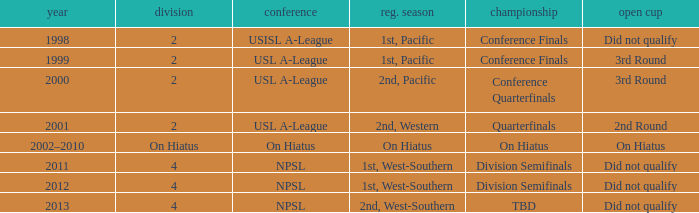Which open cup was in 2012? Did not qualify. 